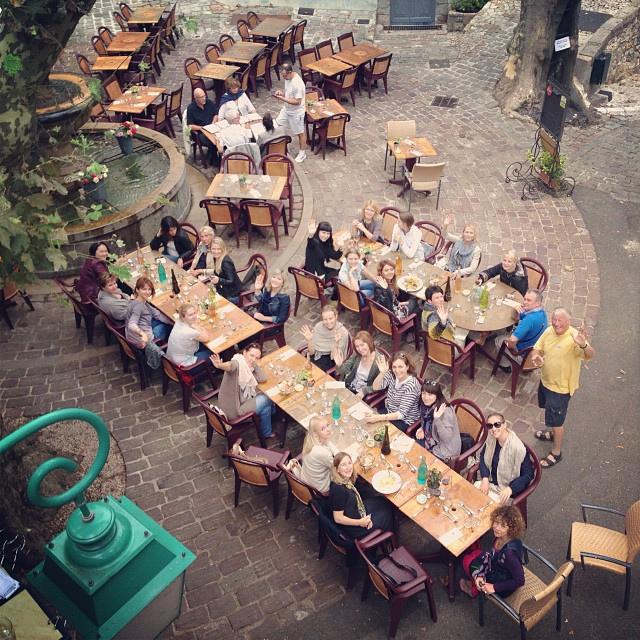What color is the top of the lamp post in the bottom left of the photo?
Write a very short answer. Green. Is it daytime?
Quick response, please. Yes. Are the guests seated at a round table?
Short answer required. No. 